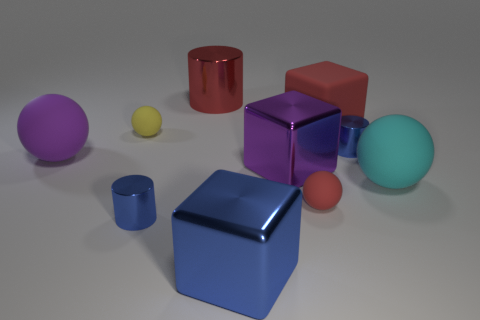Subtract all red spheres. How many blue cylinders are left? 2 Subtract 1 spheres. How many spheres are left? 3 Subtract all brown balls. Subtract all cyan cubes. How many balls are left? 4 Subtract all cylinders. How many objects are left? 7 Add 4 big cylinders. How many big cylinders exist? 5 Subtract 1 blue cylinders. How many objects are left? 9 Subtract all cyan rubber spheres. Subtract all small yellow matte things. How many objects are left? 8 Add 1 large metallic blocks. How many large metallic blocks are left? 3 